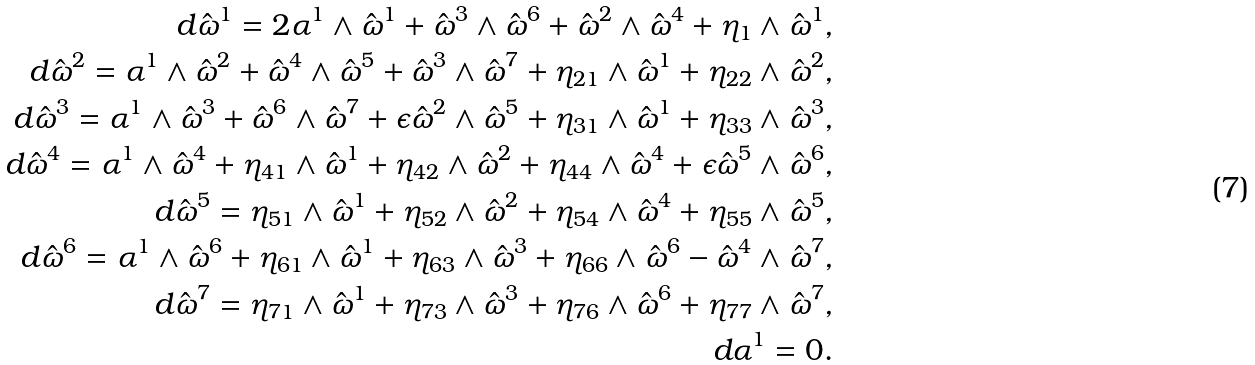Convert formula to latex. <formula><loc_0><loc_0><loc_500><loc_500>d \hat { \omega } ^ { 1 } = 2 \alpha ^ { 1 } \wedge \hat { \omega } ^ { 1 } + \hat { \omega } ^ { 3 } \wedge \hat { \omega } ^ { 6 } + \hat { \omega } ^ { 2 } \wedge \hat { \omega } ^ { 4 } + \eta _ { 1 } \wedge \hat { \omega } ^ { 1 } , \\ d \hat { \omega } ^ { 2 } = \alpha ^ { 1 } \wedge \hat { \omega } ^ { 2 } + \hat { \omega } ^ { 4 } \wedge \hat { \omega } ^ { 5 } + \hat { \omega } ^ { 3 } \wedge \hat { \omega } ^ { 7 } + \eta _ { 2 1 } \wedge \hat { \omega } ^ { 1 } + \eta _ { 2 2 } \wedge \hat { \omega } ^ { 2 } , \\ d \hat { \omega } ^ { 3 } = \alpha ^ { 1 } \wedge \hat { \omega } ^ { 3 } + \hat { \omega } ^ { 6 } \wedge \hat { \omega } ^ { 7 } + \epsilon \hat { \omega } ^ { 2 } \wedge \hat { \omega } ^ { 5 } + \eta _ { 3 1 } \wedge \hat { \omega } ^ { 1 } + \eta _ { 3 3 } \wedge \hat { \omega } ^ { 3 } , \\ d \hat { \omega } ^ { 4 } = \alpha ^ { 1 } \wedge \hat { \omega } ^ { 4 } + \eta _ { 4 1 } \wedge \hat { \omega } ^ { 1 } + \eta _ { 4 2 } \wedge \hat { \omega } ^ { 2 } + \eta _ { 4 4 } \wedge \hat { \omega } ^ { 4 } + \epsilon \hat { \omega } ^ { 5 } \wedge \hat { \omega } ^ { 6 } , \\ d \hat { \omega } ^ { 5 } = \eta _ { 5 1 } \wedge \hat { \omega } ^ { 1 } + \eta _ { 5 2 } \wedge \hat { \omega } ^ { 2 } + \eta _ { 5 4 } \wedge \hat { \omega } ^ { 4 } + \eta _ { 5 5 } \wedge \hat { \omega } ^ { 5 } , \\ d \hat { \omega } ^ { 6 } = \alpha ^ { 1 } \wedge \hat { \omega } ^ { 6 } + \eta _ { 6 1 } \wedge \hat { \omega } ^ { 1 } + \eta _ { 6 3 } \wedge \hat { \omega } ^ { 3 } + \eta _ { 6 6 } \wedge \hat { \omega } ^ { 6 } - \hat { \omega } ^ { 4 } \wedge \hat { \omega } ^ { 7 } , \\ d \hat { \omega } ^ { 7 } = \eta _ { 7 1 } \wedge \hat { \omega } ^ { 1 } + \eta _ { 7 3 } \wedge \hat { \omega } ^ { 3 } + \eta _ { 7 6 } \wedge \hat { \omega } ^ { 6 } + \eta _ { 7 7 } \wedge \hat { \omega } ^ { 7 } , \\ d \alpha ^ { 1 } = 0 .</formula> 